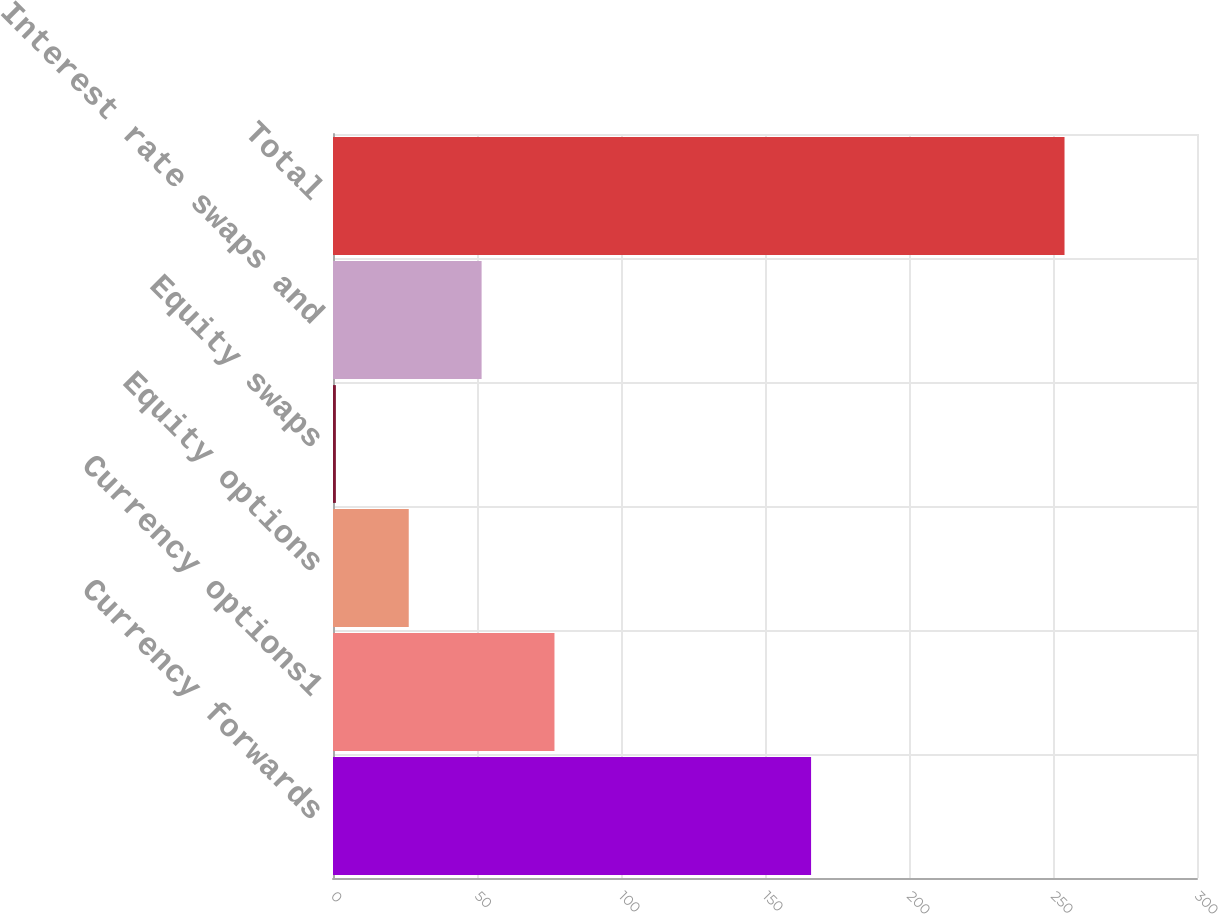Convert chart to OTSL. <chart><loc_0><loc_0><loc_500><loc_500><bar_chart><fcel>Currency forwards<fcel>Currency options1<fcel>Equity options<fcel>Equity swaps<fcel>Interest rate swaps and<fcel>Total<nl><fcel>166<fcel>76.9<fcel>26.3<fcel>1<fcel>51.6<fcel>254<nl></chart> 